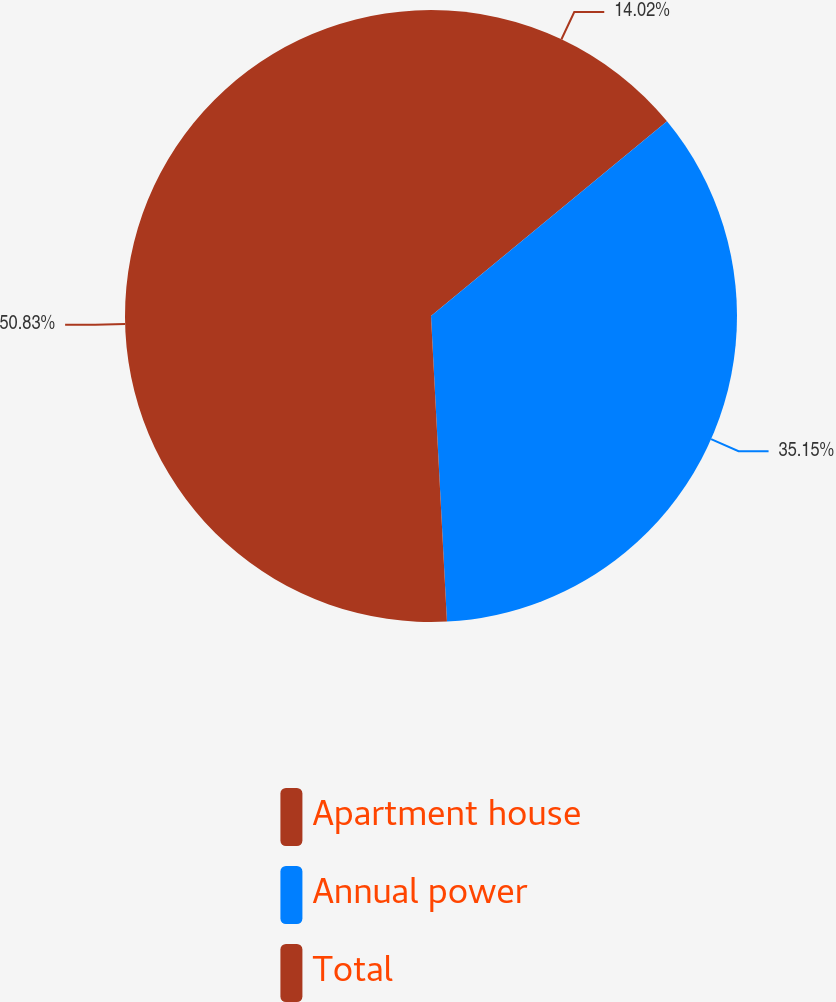<chart> <loc_0><loc_0><loc_500><loc_500><pie_chart><fcel>Apartment house<fcel>Annual power<fcel>Total<nl><fcel>14.02%<fcel>35.15%<fcel>50.83%<nl></chart> 